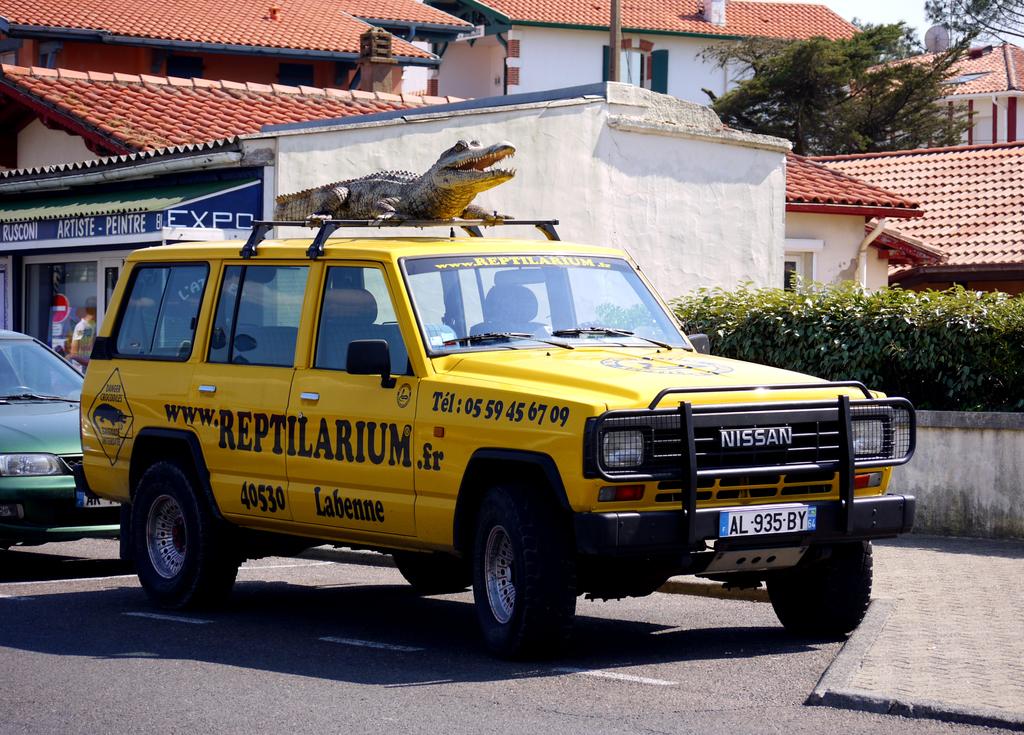What is the plate number?
Offer a very short reply. Al 935 by. What is the telephone number shown?
Ensure brevity in your answer.  05 59 45 67 09. 